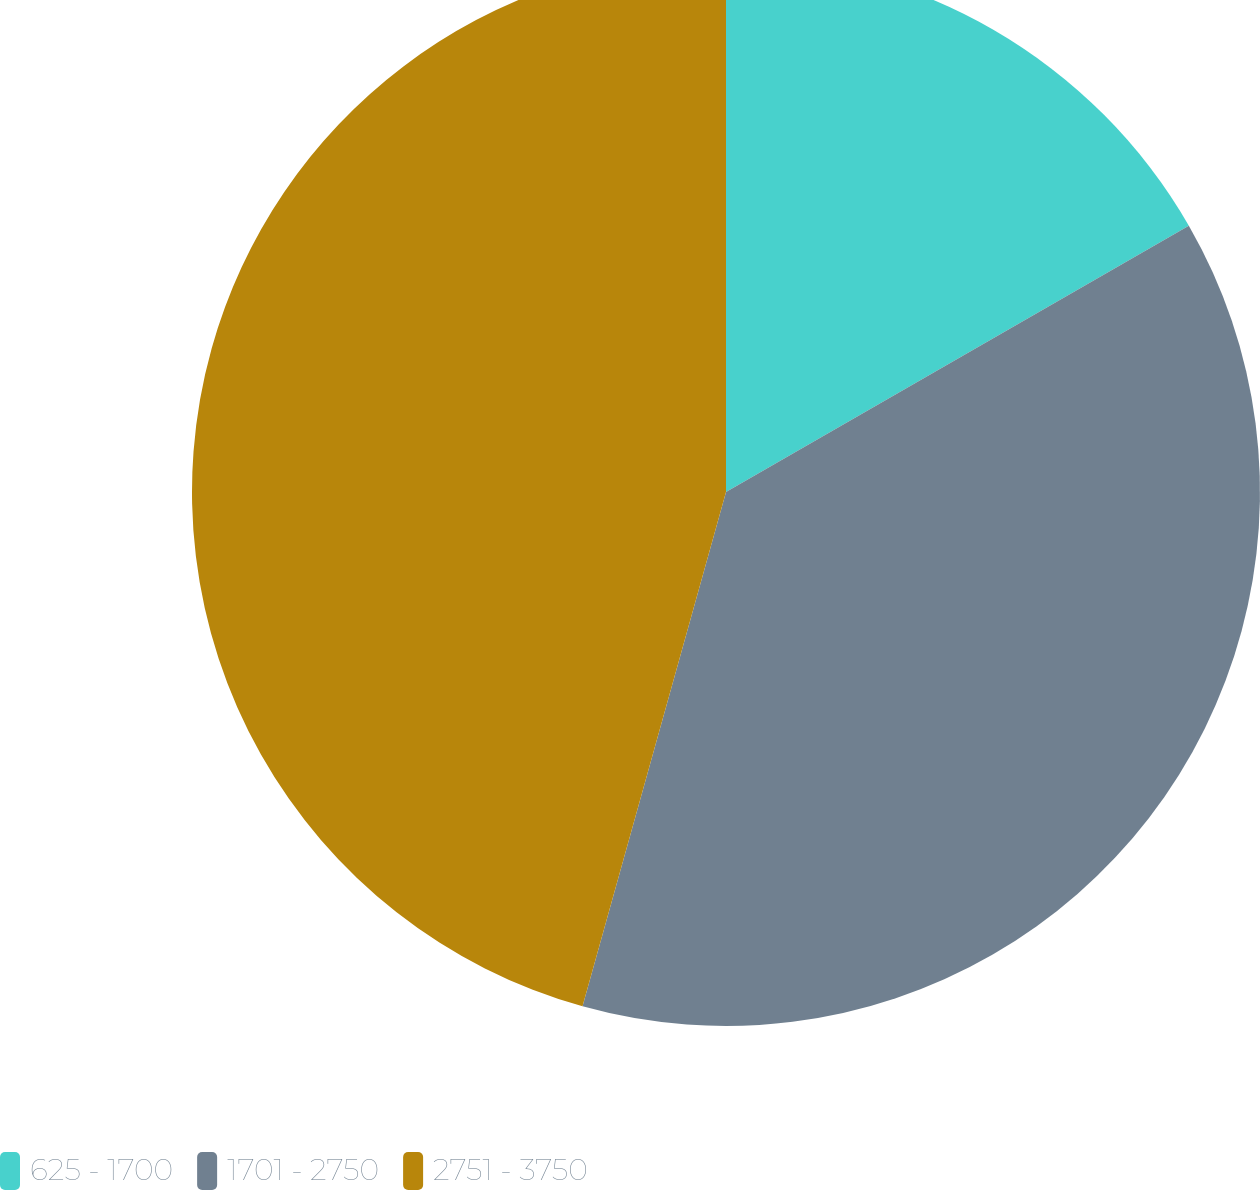Convert chart to OTSL. <chart><loc_0><loc_0><loc_500><loc_500><pie_chart><fcel>625 - 1700<fcel>1701 - 2750<fcel>2751 - 3750<nl><fcel>16.69%<fcel>37.64%<fcel>45.67%<nl></chart> 